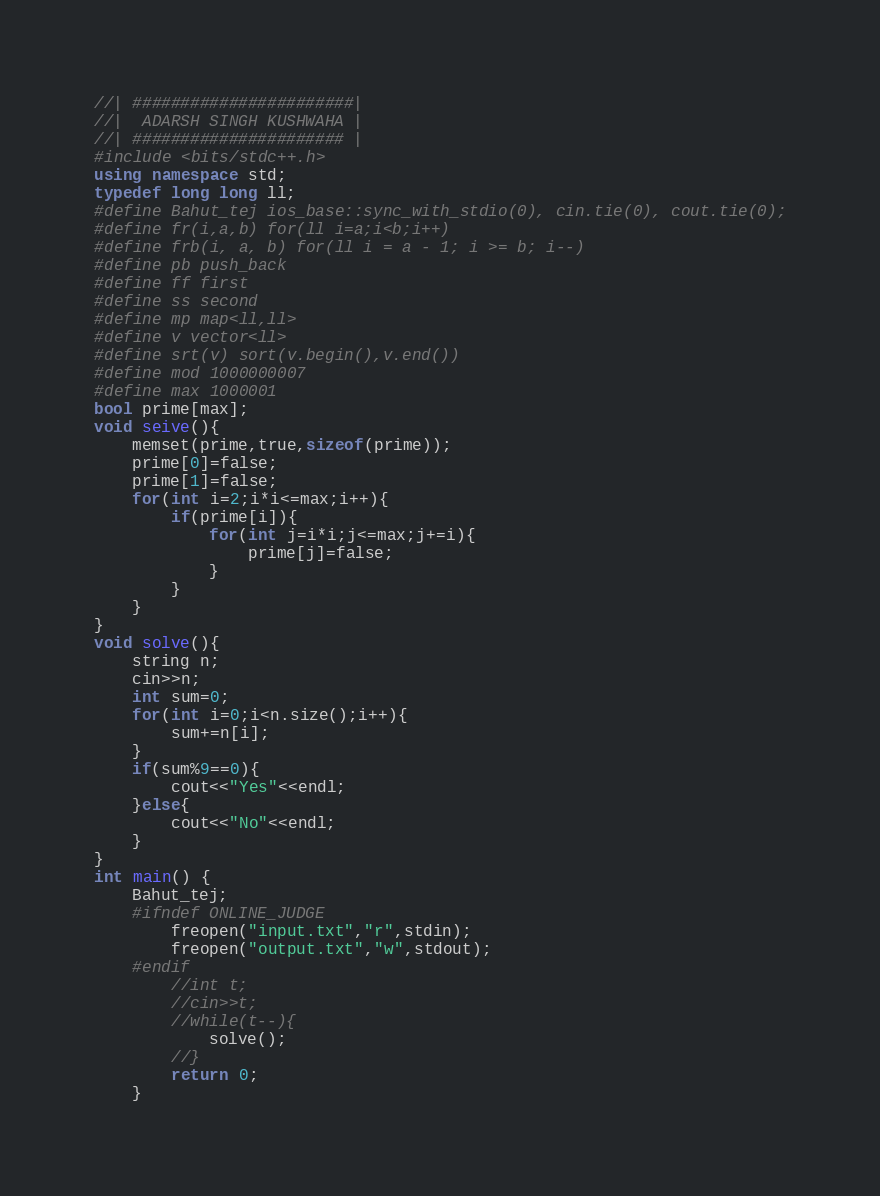<code> <loc_0><loc_0><loc_500><loc_500><_C++_>//| #######################|
//|  ADARSH SINGH KUSHWAHA |
//| ###################### | 
#include <bits/stdc++.h>
using namespace std;
typedef long long ll;
#define Bahut_tej ios_base::sync_with_stdio(0), cin.tie(0), cout.tie(0);
#define fr(i,a,b) for(ll i=a;i<b;i++)
#define frb(i, a, b) for(ll i = a - 1; i >= b; i--)
#define pb push_back
#define ff first
#define ss second
#define mp map<ll,ll>
#define v vector<ll>
#define srt(v) sort(v.begin(),v.end())
#define mod 1000000007 
#define max 1000001
bool prime[max];
void seive(){
    memset(prime,true,sizeof(prime));
    prime[0]=false;
    prime[1]=false;
    for(int i=2;i*i<=max;i++){
        if(prime[i]){
            for(int j=i*i;j<=max;j+=i){
                prime[j]=false;
            }
        }
    }
}
void solve(){
    string n;
    cin>>n;
    int sum=0;
    for(int i=0;i<n.size();i++){
        sum+=n[i];
    }
    if(sum%9==0){
        cout<<"Yes"<<endl;
    }else{
        cout<<"No"<<endl;
    }
}
int main() {
    Bahut_tej;
    #ifndef ONLINE_JUDGE
        freopen("input.txt","r",stdin);
        freopen("output.txt","w",stdout);
    #endif  
        //int t;
        //cin>>t;
        //while(t--){
            solve();
        //}
        return 0;
    }</code> 